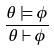<formula> <loc_0><loc_0><loc_500><loc_500>\frac { \theta \models \phi } { \theta \vdash \phi }</formula> 